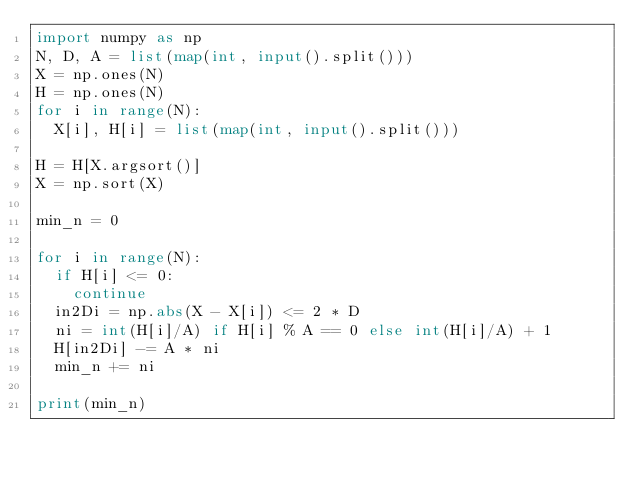<code> <loc_0><loc_0><loc_500><loc_500><_Python_>import numpy as np
N, D, A = list(map(int, input().split()))
X = np.ones(N)
H = np.ones(N)
for i in range(N):
  X[i], H[i] = list(map(int, input().split()))

H = H[X.argsort()]
X = np.sort(X)

min_n = 0

for i in range(N):
  if H[i] <= 0:
    continue
  in2Di = np.abs(X - X[i]) <= 2 * D
  ni = int(H[i]/A) if H[i] % A == 0 else int(H[i]/A) + 1
  H[in2Di] -= A * ni
  min_n += ni
  
print(min_n)</code> 